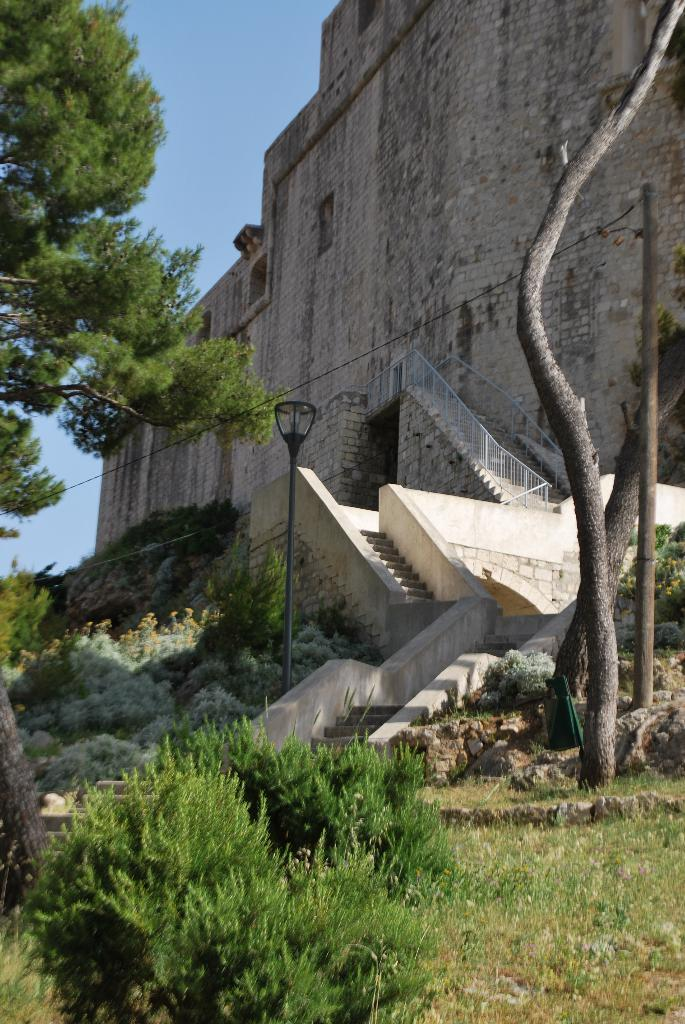What type of structure is visible in the image? There is a building in the image. What is another object that can be seen in the image? There is a light pole in the image. Are there any architectural features present in the image? Yes, there are stairs in the image. What type of vegetation can be seen in the image? There are plants, trees, and grass in the image. What is visible at the top of the image? The sky is visible at the top of the image. How many pairs of shoes are hanging from the light pole in the image? There are no shoes hanging from the light pole in the image. What message of hope can be seen on the building in the image? There is no message of hope present on the building in the image. 